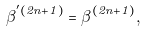Convert formula to latex. <formula><loc_0><loc_0><loc_500><loc_500>\beta ^ { ^ { \prime } ( 2 n + 1 ) } = \beta ^ { ( 2 n + 1 ) } ,</formula> 